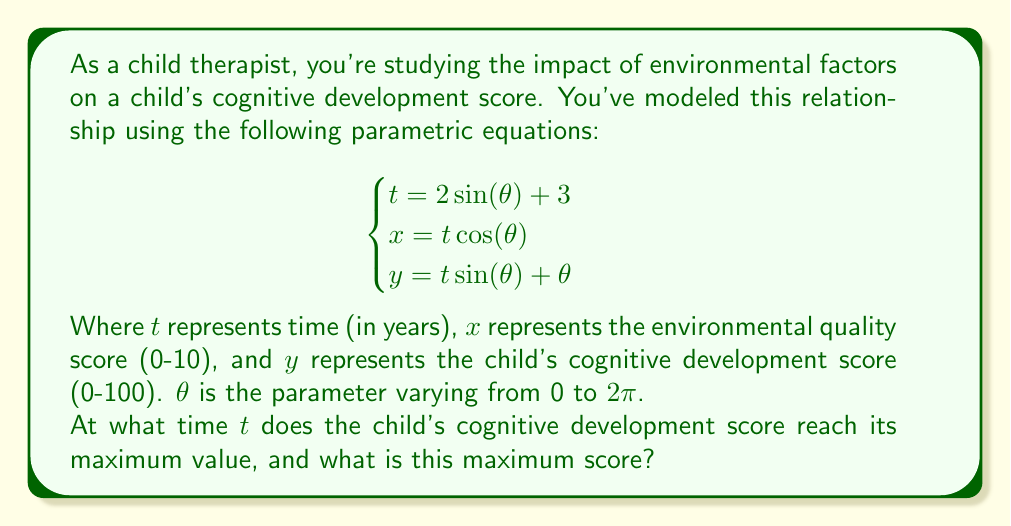Teach me how to tackle this problem. To solve this problem, we need to follow these steps:

1) First, we need to find the maximum value of $y$. Since $y = t\sin(\theta) + \theta$, we can substitute $t = 2\sin(\theta) + 3$:

   $y = (2\sin(\theta) + 3)\sin(\theta) + \theta$
   $y = 2\sin^2(\theta) + 3\sin(\theta) + \theta$

2) To find the maximum, we need to differentiate $y$ with respect to $\theta$ and set it to zero:

   $\frac{dy}{d\theta} = 4\sin(\theta)\cos(\theta) + 3\cos(\theta) + 1 = 0$

3) This equation is complex to solve analytically. We can use numerical methods or graphing to find that the maximum occurs at approximately $\theta \approx 2.554$ radians.

4) Now that we have $\theta$, we can calculate $t$:

   $t = 2\sin(2.554) + 3 \approx 4.834$ years

5) And we can calculate the maximum $y$ value:

   $y = 2\sin^2(2.554) + 3\sin(2.554) + 2.554 \approx 5.575$

6) However, remember that $y$ represents the cognitive development score on a scale of 0-100. We need to scale this value:

   $y_{scaled} = y * 100 / (2\pi) \approx 88.75$

Therefore, the child's cognitive development score reaches its maximum of approximately 88.75 at time $t \approx 4.834$ years.
Answer: The child's cognitive development score reaches its maximum value of approximately 88.75 at time $t \approx 4.834$ years. 